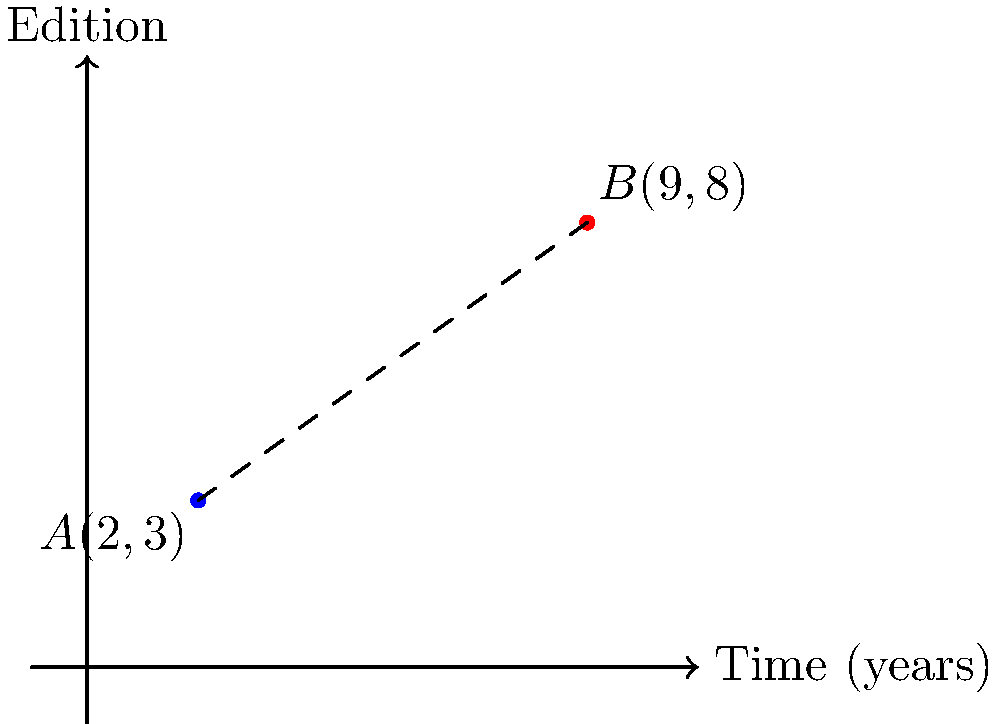In your study of early editions of classic works, you've plotted two significant editions on a coordinate plane. The x-axis represents the time (in years) since the original publication, and the y-axis represents the edition number. Edition A is represented by the point (2,3), and Edition B by (9,8). Calculate the temporal distance between these two editions, rounded to two decimal places. To find the temporal distance between the two editions, we need to calculate the distance between the two points on the coordinate plane. We can use the distance formula derived from the Pythagorean theorem:

$$d = \sqrt{(x_2 - x_1)^2 + (y_2 - y_1)^2}$$

Where $(x_1, y_1)$ represents the coordinates of point A, and $(x_2, y_2)$ represents the coordinates of point B.

Step 1: Identify the coordinates
Point A: $(x_1, y_1) = (2, 3)$
Point B: $(x_2, y_2) = (9, 8)$

Step 2: Plug the values into the distance formula
$$d = \sqrt{(9 - 2)^2 + (8 - 3)^2}$$

Step 3: Simplify the expressions inside the parentheses
$$d = \sqrt{7^2 + 5^2}$$

Step 4: Calculate the squares
$$d = \sqrt{49 + 25}$$

Step 5: Add the values under the square root
$$d = \sqrt{74}$$

Step 6: Calculate the square root and round to two decimal places
$$d \approx 8.60$$

The temporal distance between the two editions is approximately 8.60 years.
Answer: 8.60 years 